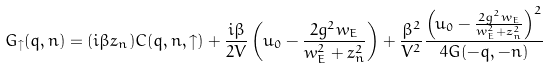Convert formula to latex. <formula><loc_0><loc_0><loc_500><loc_500>G _ { \uparrow } ( { q } , n ) = ( i \beta z _ { n } ) C ( { q } , n , \uparrow ) + \frac { i \beta } { 2 V } \left ( u _ { 0 } - \frac { 2 g ^ { 2 } w _ { E } } { w _ { E } ^ { 2 } + z _ { n } ^ { 2 } } \right ) + \frac { \beta ^ { 2 } } { V ^ { 2 } } \frac { \left ( u _ { 0 } - \frac { 2 g ^ { 2 } w _ { E } } { w _ { E } ^ { 2 } + z _ { n } ^ { 2 } } \right ) ^ { 2 } } { 4 G ( - { q } , - n ) }</formula> 